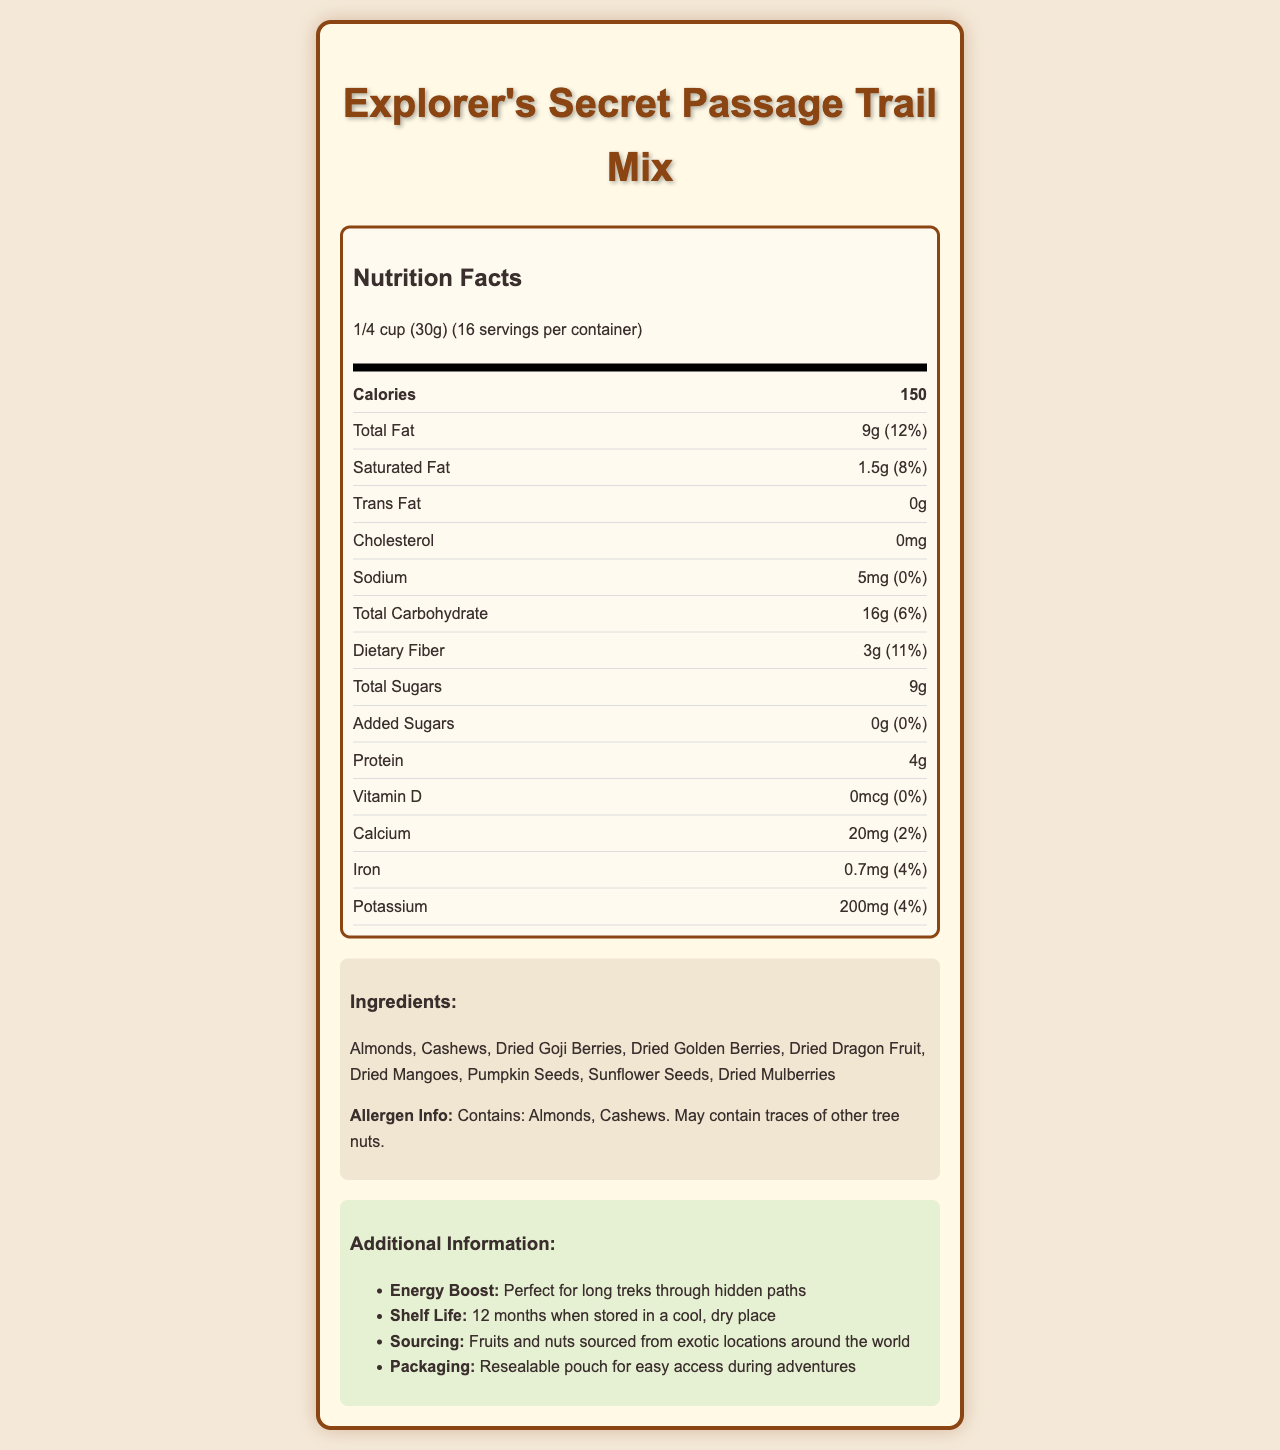what is the serving size? The serving size is clearly listed at the beginning of the nutrition facts, right under the product name.
Answer: 1/4 cup (30g) how many servings are in the container? The number of servings per container is indicated right next to the serving size under the nutrition facts header.
Answer: 16 how many calories are there per serving? The calories per serving are listed clearly in the nutrition facts, right under the serving size information.
Answer: 150 what is the amount of total fat per serving? The total fat amount per serving is mentioned in the nutrition facts section under the calories information.
Answer: 9g how much dietary fiber is in one serving? The amount of dietary fiber per serving is specified in the nutrition facts under total carbohydrate.
Answer: 3g what type of nuts are included in the ingredients? A. Almonds and Cashews B. Pecans and Walnuts C. Hazelnuts and Chestnuts The ingredients list specifies that the nuts used are almonds and cashews.
Answer: A what is the daily value percentage of potassium in one serving? A. 2% B. 5% C. 4% The daily value percentage for potassium is 4%, as listed in the nutrition facts under the potassium section.
Answer: C does this trail mix contain added sugars? The nutrition facts clearly mention that the amount for added sugars is 0g, which means there are no added sugars.
Answer: No is there any cholesterol in the trail mix? The nutrition facts state that the cholesterol amount is 0mg, indicating there is no cholesterol.
Answer: No describe the main idea of the document. The main idea of the document is to inform consumers about the nutritional content and ingredients of the trail mix, along with additional product details and benefits.
Answer: The document provides detailed nutrition facts and additional information about the "Explorer's Secret Passage Trail Mix." It includes serving size, calories, and detailed nutrient amounts per serving. It also lists the ingredients, allergen information, and other product-related details like energy boost, shelf life, sourcing, and packaging. what is the vitamin C content in this trail mix? The document does not provide any information about the vitamin C content in the trail mix, making it impossible to determine from the given information.
Answer: Cannot be determined 